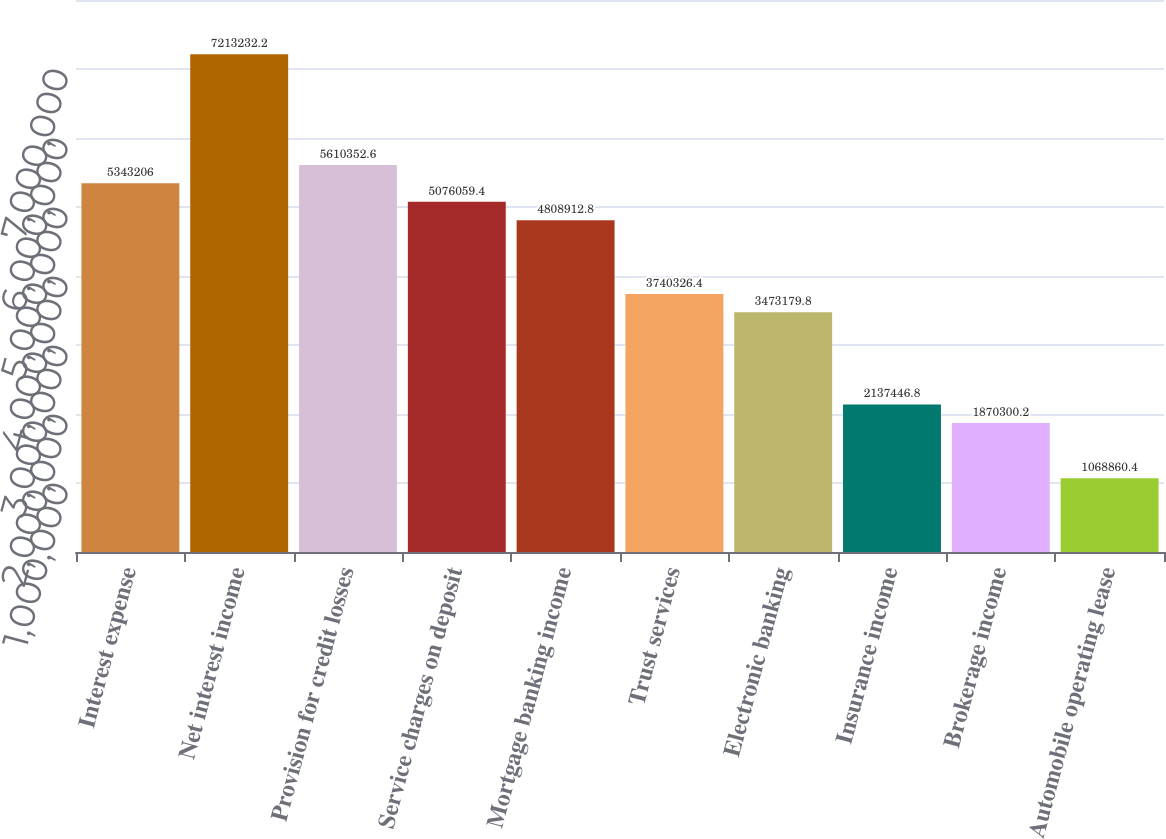<chart> <loc_0><loc_0><loc_500><loc_500><bar_chart><fcel>Interest expense<fcel>Net interest income<fcel>Provision for credit losses<fcel>Service charges on deposit<fcel>Mortgage banking income<fcel>Trust services<fcel>Electronic banking<fcel>Insurance income<fcel>Brokerage income<fcel>Automobile operating lease<nl><fcel>5.34321e+06<fcel>7.21323e+06<fcel>5.61035e+06<fcel>5.07606e+06<fcel>4.80891e+06<fcel>3.74033e+06<fcel>3.47318e+06<fcel>2.13745e+06<fcel>1.8703e+06<fcel>1.06886e+06<nl></chart> 